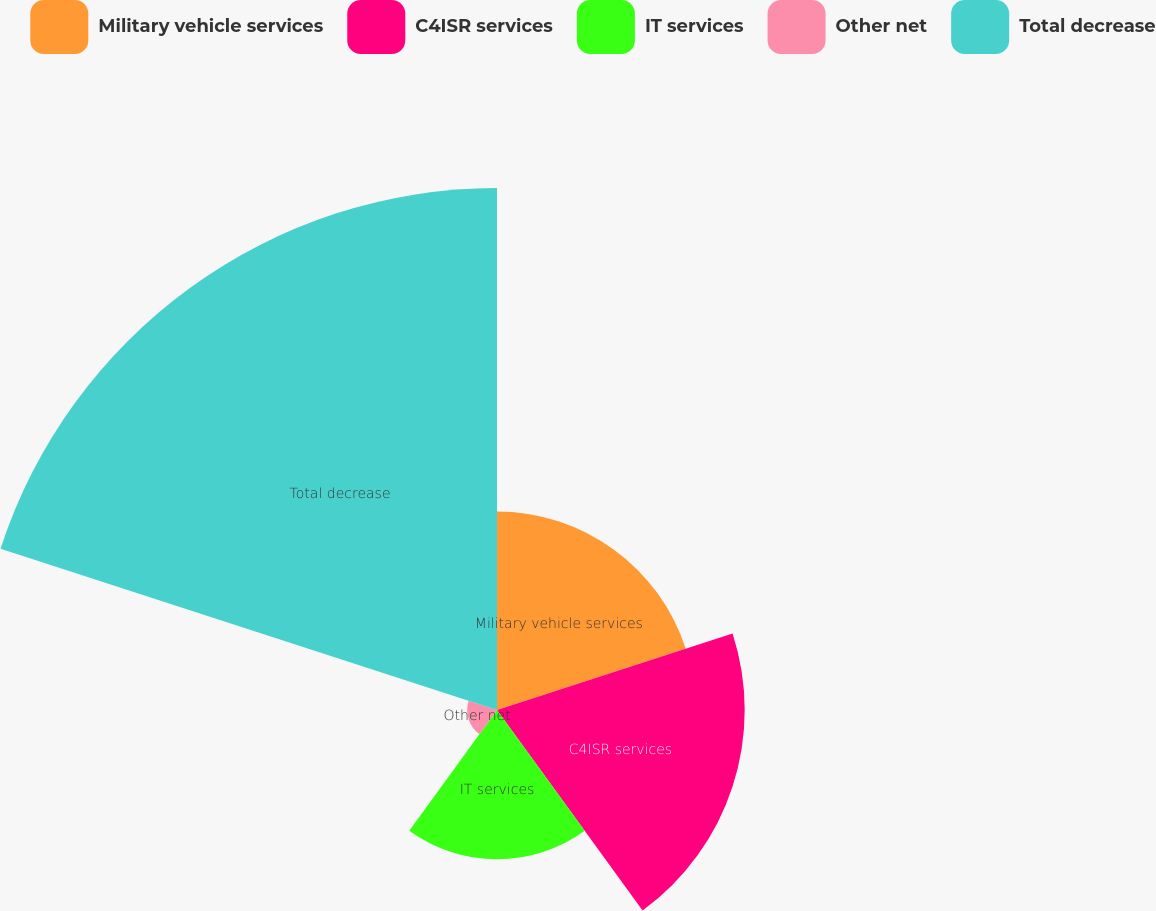<chart> <loc_0><loc_0><loc_500><loc_500><pie_chart><fcel>Military vehicle services<fcel>C4ISR services<fcel>IT services<fcel>Other net<fcel>Total decrease<nl><fcel>17.3%<fcel>21.59%<fcel>13.01%<fcel>2.6%<fcel>45.5%<nl></chart> 